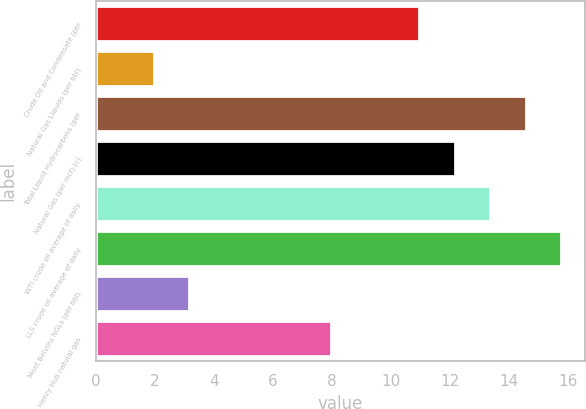Convert chart to OTSL. <chart><loc_0><loc_0><loc_500><loc_500><bar_chart><fcel>Crude Oil and Condensate (per<fcel>Natural Gas Liquids (per bbl)<fcel>Total Liquid Hydrocarbons (per<fcel>Natural Gas (per mcf) (c)<fcel>WTI crude oil average of daily<fcel>LLS crude oil average of daily<fcel>Mont Belvieu NGLs (per bbl)<fcel>Henry Hub natural gas<nl><fcel>11<fcel>2<fcel>14.6<fcel>12.2<fcel>13.4<fcel>15.8<fcel>3.2<fcel>8<nl></chart> 